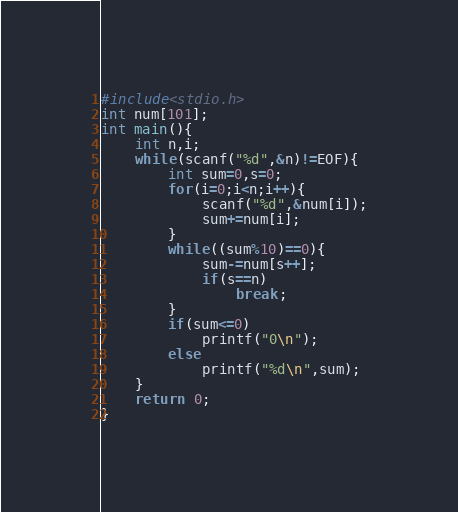Convert code to text. <code><loc_0><loc_0><loc_500><loc_500><_C_>#include<stdio.h>
int num[101];
int main(){
	int n,i;
	while(scanf("%d",&n)!=EOF){
		int sum=0,s=0;
		for(i=0;i<n;i++){
			scanf("%d",&num[i]);
			sum+=num[i];
		}
		while((sum%10)==0){
			sum-=num[s++];
			if(s==n)
				break;
		}
		if(sum<=0)
			printf("0\n");
		else
			printf("%d\n",sum);
	}
	return 0;
}</code> 